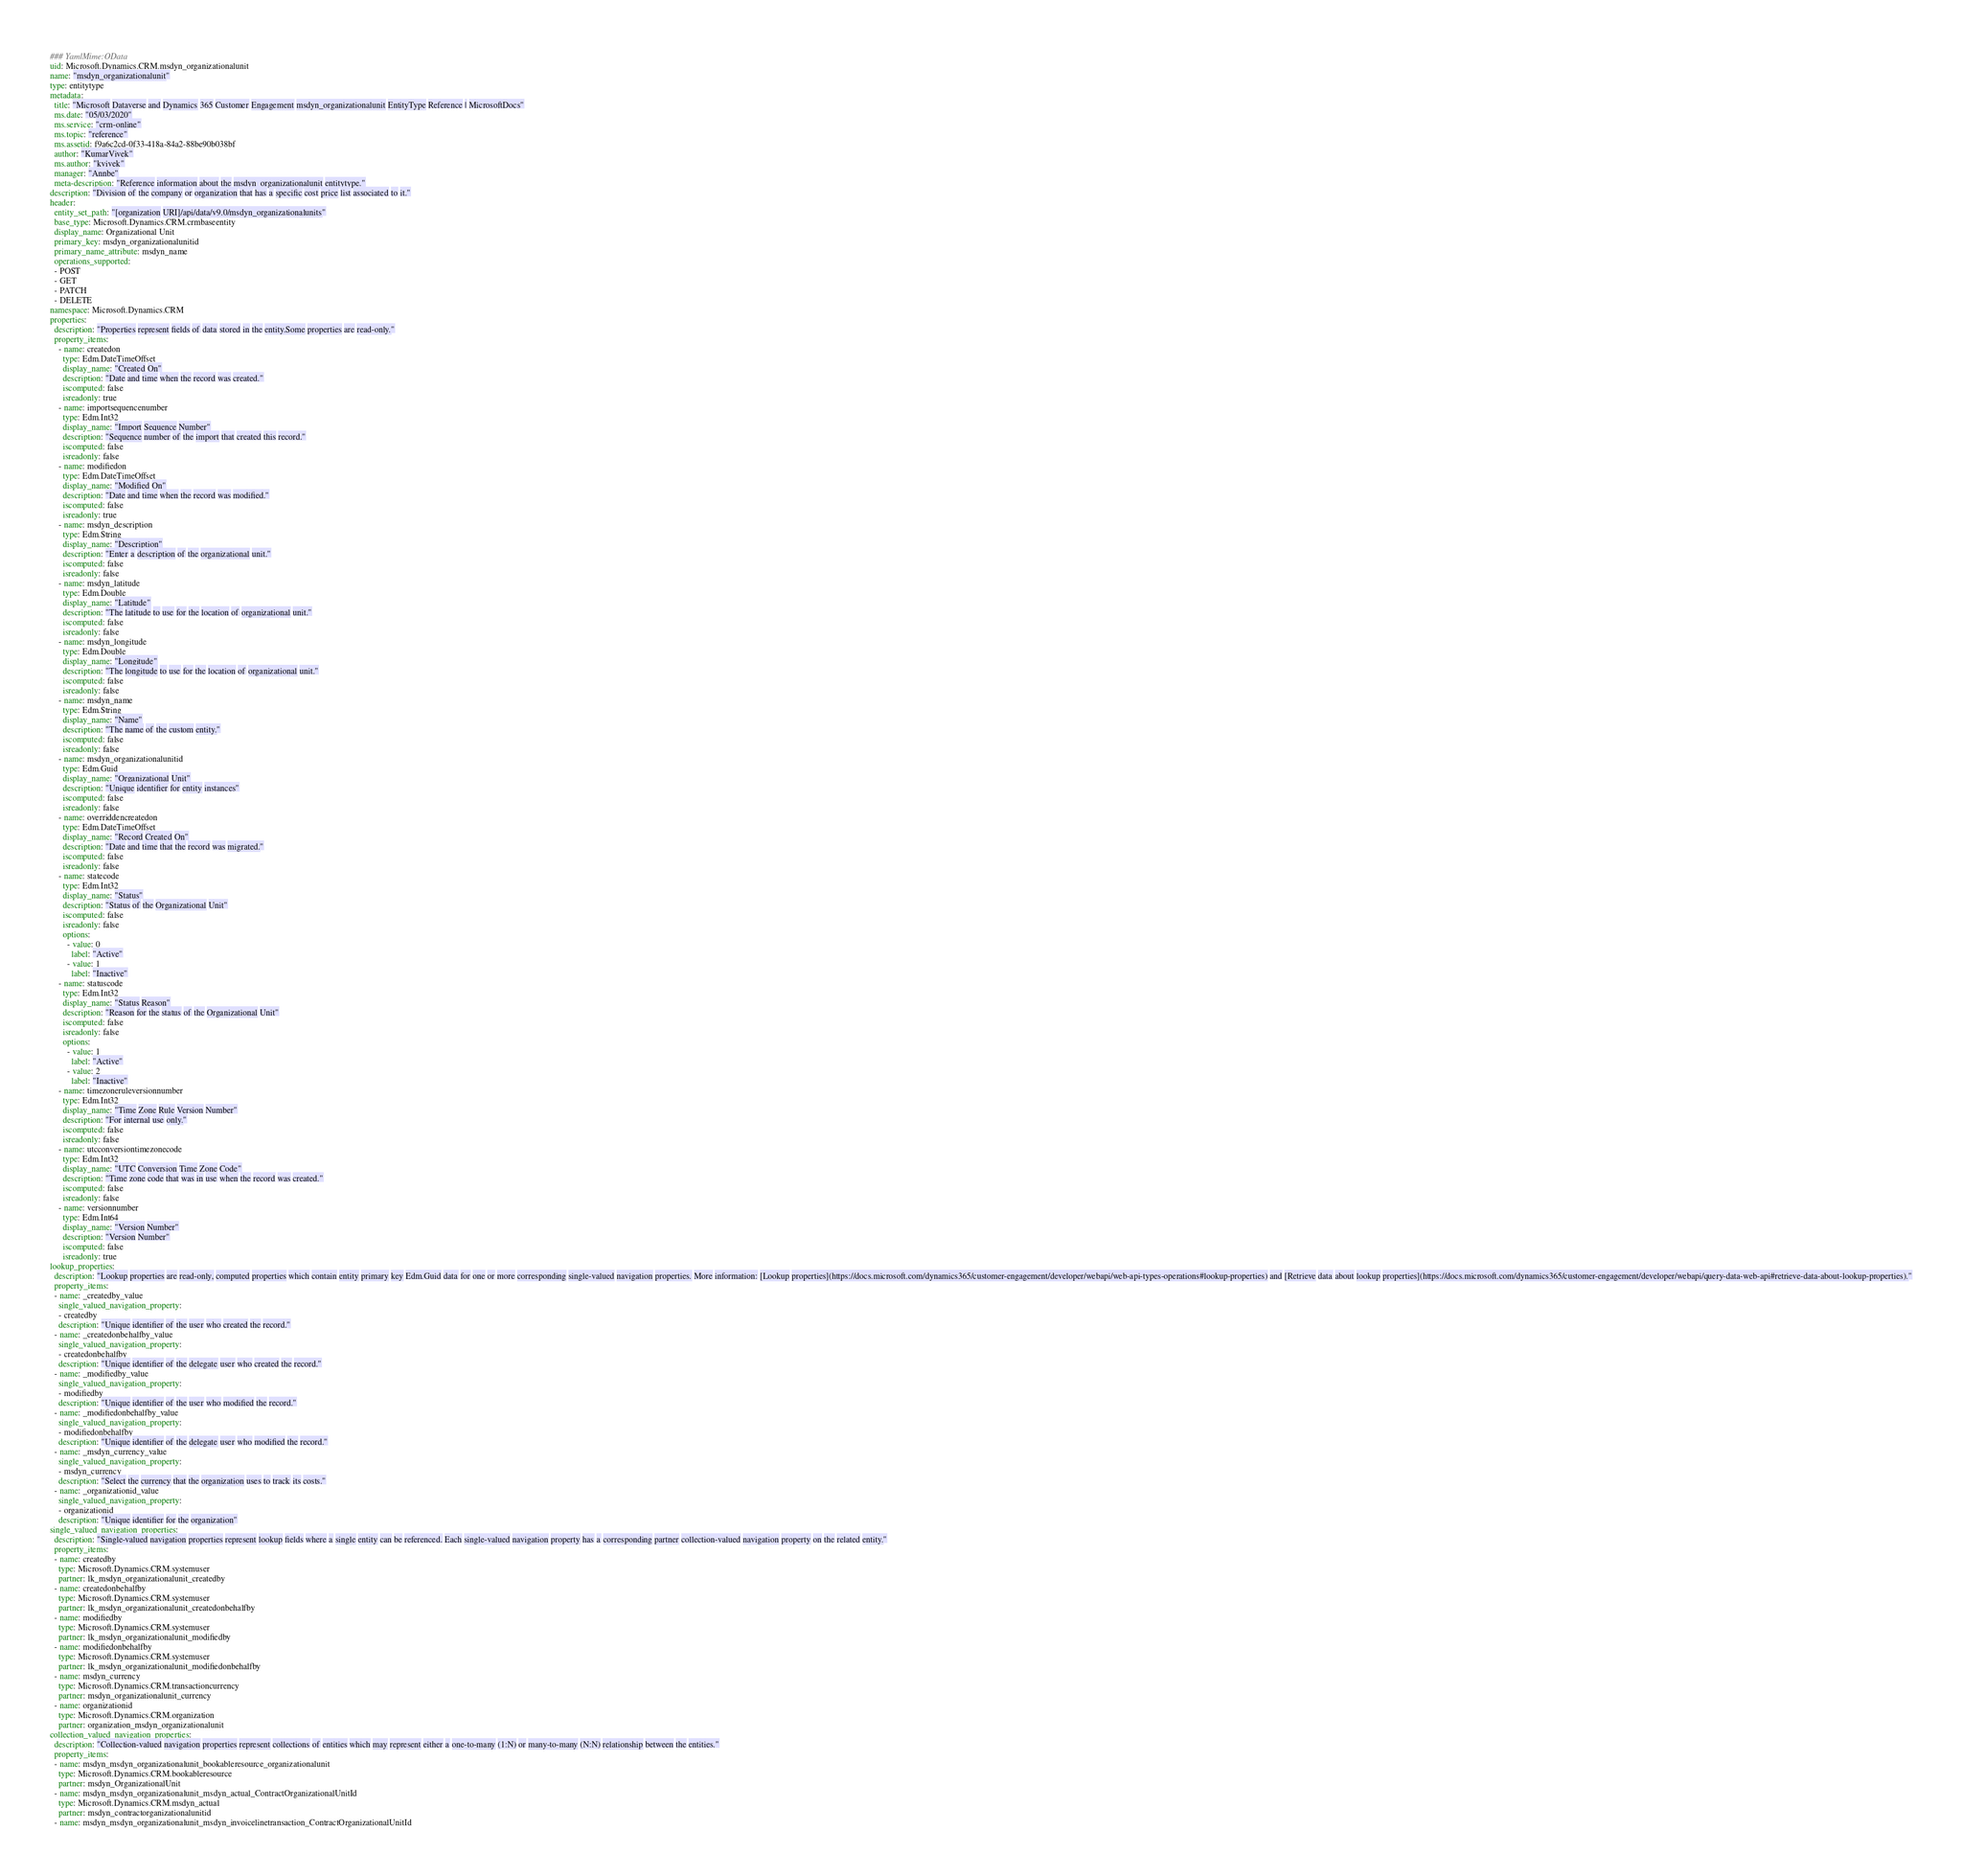<code> <loc_0><loc_0><loc_500><loc_500><_YAML_>### YamlMime:OData
uid: Microsoft.Dynamics.CRM.msdyn_organizationalunit
name: "msdyn_organizationalunit"
type: entitytype
metadata: 
  title: "Microsoft Dataverse and Dynamics 365 Customer Engagement msdyn_organizationalunit EntityType Reference | MicrosoftDocs"
  ms.date: "05/03/2020"
  ms.service: "crm-online"
  ms.topic: "reference"
  ms.assetid: f9a6c2cd-0f33-418a-84a2-88be90b038bf
  author: "KumarVivek"
  ms.author: "kvivek"
  manager: "Annbe"
  meta-description: "Reference information about the msdyn_organizationalunit entitytype."
description: "Division of the company or organization that has a specific cost price list associated to it."
header:
  entity_set_path: "[organization URI]/api/data/v9.0/msdyn_organizationalunits"
  base_type: Microsoft.Dynamics.CRM.crmbaseentity
  display_name: Organizational Unit
  primary_key: msdyn_organizationalunitid
  primary_name_attribute: msdyn_name
  operations_supported:
  - POST
  - GET
  - PATCH
  - DELETE
namespace: Microsoft.Dynamics.CRM
properties:
  description: "Properties represent fields of data stored in the entity.Some properties are read-only."
  property_items:
    - name: createdon
      type: Edm.DateTimeOffset
      display_name: "Created On"
      description: "Date and time when the record was created."
      iscomputed: false
      isreadonly: true
    - name: importsequencenumber
      type: Edm.Int32
      display_name: "Import Sequence Number"
      description: "Sequence number of the import that created this record."
      iscomputed: false
      isreadonly: false
    - name: modifiedon
      type: Edm.DateTimeOffset
      display_name: "Modified On"
      description: "Date and time when the record was modified."
      iscomputed: false
      isreadonly: true
    - name: msdyn_description
      type: Edm.String
      display_name: "Description"
      description: "Enter a description of the organizational unit."
      iscomputed: false
      isreadonly: false
    - name: msdyn_latitude
      type: Edm.Double
      display_name: "Latitude"
      description: "The latitude to use for the location of organizational unit."
      iscomputed: false
      isreadonly: false
    - name: msdyn_longitude
      type: Edm.Double
      display_name: "Longitude"
      description: "The longitude to use for the location of organizational unit."
      iscomputed: false
      isreadonly: false
    - name: msdyn_name
      type: Edm.String
      display_name: "Name"
      description: "The name of the custom entity."
      iscomputed: false
      isreadonly: false
    - name: msdyn_organizationalunitid
      type: Edm.Guid
      display_name: "Organizational Unit"
      description: "Unique identifier for entity instances"
      iscomputed: false
      isreadonly: false
    - name: overriddencreatedon
      type: Edm.DateTimeOffset
      display_name: "Record Created On"
      description: "Date and time that the record was migrated."
      iscomputed: false
      isreadonly: false
    - name: statecode
      type: Edm.Int32
      display_name: "Status"
      description: "Status of the Organizational Unit"
      iscomputed: false
      isreadonly: false
      options:
        - value: 0
          label: "Active"
        - value: 1
          label: "Inactive"
    - name: statuscode
      type: Edm.Int32
      display_name: "Status Reason"
      description: "Reason for the status of the Organizational Unit"
      iscomputed: false
      isreadonly: false
      options:
        - value: 1
          label: "Active"
        - value: 2
          label: "Inactive"
    - name: timezoneruleversionnumber
      type: Edm.Int32
      display_name: "Time Zone Rule Version Number"
      description: "For internal use only."
      iscomputed: false
      isreadonly: false
    - name: utcconversiontimezonecode
      type: Edm.Int32
      display_name: "UTC Conversion Time Zone Code"
      description: "Time zone code that was in use when the record was created."
      iscomputed: false
      isreadonly: false
    - name: versionnumber
      type: Edm.Int64
      display_name: "Version Number"
      description: "Version Number"
      iscomputed: false
      isreadonly: true
lookup_properties:
  description: "Lookup properties are read-only, computed properties which contain entity primary key Edm.Guid data for one or more corresponding single-valued navigation properties. More information: [Lookup properties](https://docs.microsoft.com/dynamics365/customer-engagement/developer/webapi/web-api-types-operations#lookup-properties) and [Retrieve data about lookup properties](https://docs.microsoft.com/dynamics365/customer-engagement/developer/webapi/query-data-web-api#retrieve-data-about-lookup-properties)."
  property_items:
  - name: _createdby_value
    single_valued_navigation_property:
    - createdby
    description: "Unique identifier of the user who created the record."
  - name: _createdonbehalfby_value
    single_valued_navigation_property:
    - createdonbehalfby
    description: "Unique identifier of the delegate user who created the record."
  - name: _modifiedby_value
    single_valued_navigation_property:
    - modifiedby
    description: "Unique identifier of the user who modified the record."
  - name: _modifiedonbehalfby_value
    single_valued_navigation_property:
    - modifiedonbehalfby
    description: "Unique identifier of the delegate user who modified the record."
  - name: _msdyn_currency_value
    single_valued_navigation_property:
    - msdyn_currency
    description: "Select the currency that the organization uses to track its costs."
  - name: _organizationid_value
    single_valued_navigation_property:
    - organizationid
    description: "Unique identifier for the organization"
single_valued_navigation_properties:
  description: "Single-valued navigation properties represent lookup fields where a single entity can be referenced. Each single-valued navigation property has a corresponding partner collection-valued navigation property on the related entity."
  property_items:
  - name: createdby
    type: Microsoft.Dynamics.CRM.systemuser
    partner: lk_msdyn_organizationalunit_createdby
  - name: createdonbehalfby
    type: Microsoft.Dynamics.CRM.systemuser
    partner: lk_msdyn_organizationalunit_createdonbehalfby
  - name: modifiedby
    type: Microsoft.Dynamics.CRM.systemuser
    partner: lk_msdyn_organizationalunit_modifiedby
  - name: modifiedonbehalfby
    type: Microsoft.Dynamics.CRM.systemuser
    partner: lk_msdyn_organizationalunit_modifiedonbehalfby
  - name: msdyn_currency
    type: Microsoft.Dynamics.CRM.transactioncurrency
    partner: msdyn_organizationalunit_currency
  - name: organizationid
    type: Microsoft.Dynamics.CRM.organization
    partner: organization_msdyn_organizationalunit
collection_valued_navigation_properties:
  description: "Collection-valued navigation properties represent collections of entities which may represent either a one-to-many (1:N) or many-to-many (N:N) relationship between the entities."
  property_items:
  - name: msdyn_msdyn_organizationalunit_bookableresource_organizationalunit
    type: Microsoft.Dynamics.CRM.bookableresource
    partner: msdyn_OrganizationalUnit
  - name: msdyn_msdyn_organizationalunit_msdyn_actual_ContractOrganizationalUnitId
    type: Microsoft.Dynamics.CRM.msdyn_actual
    partner: msdyn_contractorganizationalunitid
  - name: msdyn_msdyn_organizationalunit_msdyn_invoicelinetransaction_ContractOrganizationalUnitId</code> 